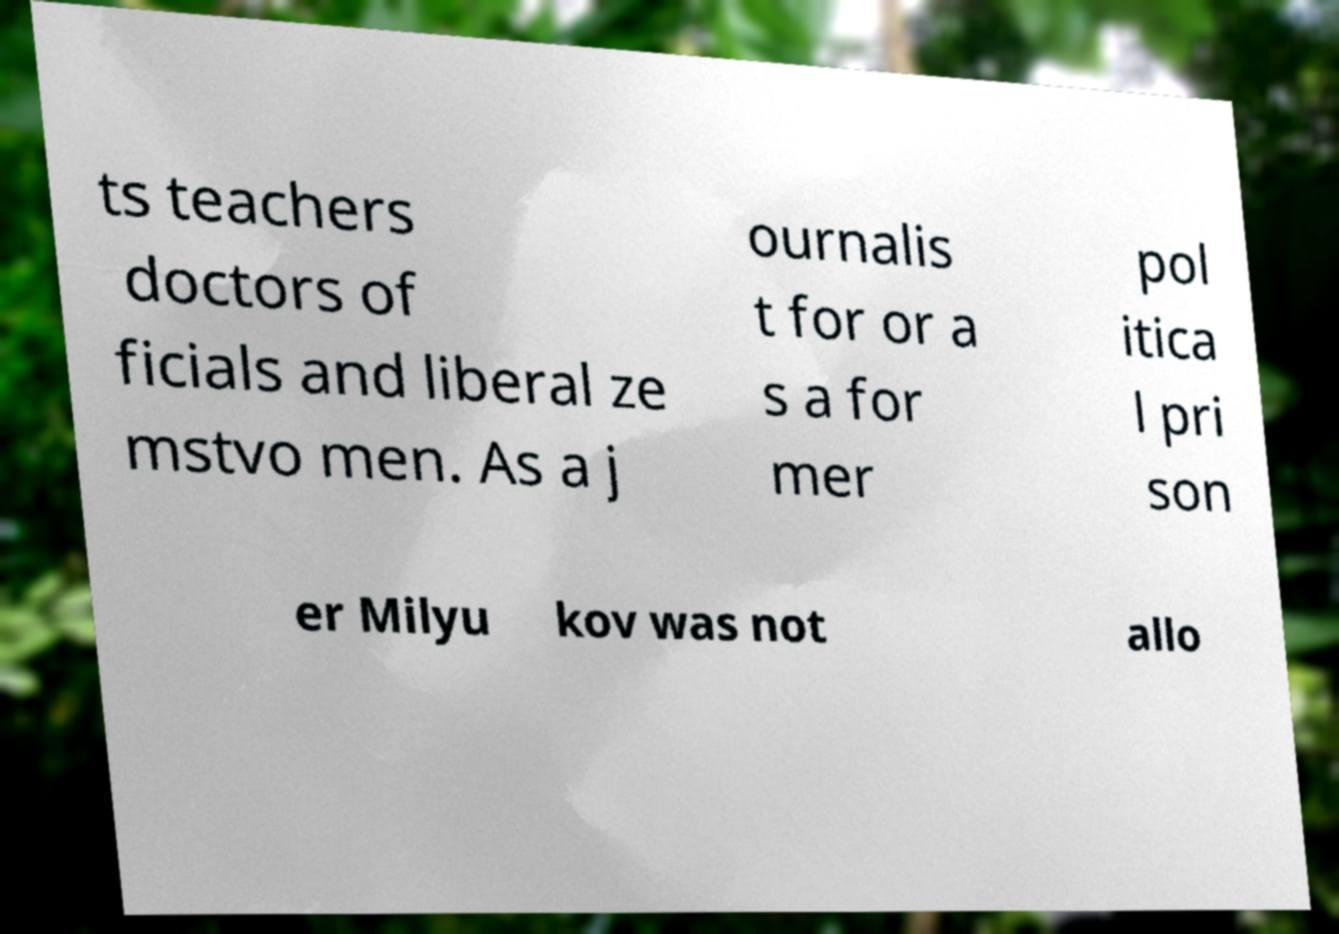Could you extract and type out the text from this image? ts teachers doctors of ficials and liberal ze mstvo men. As a j ournalis t for or a s a for mer pol itica l pri son er Milyu kov was not allo 